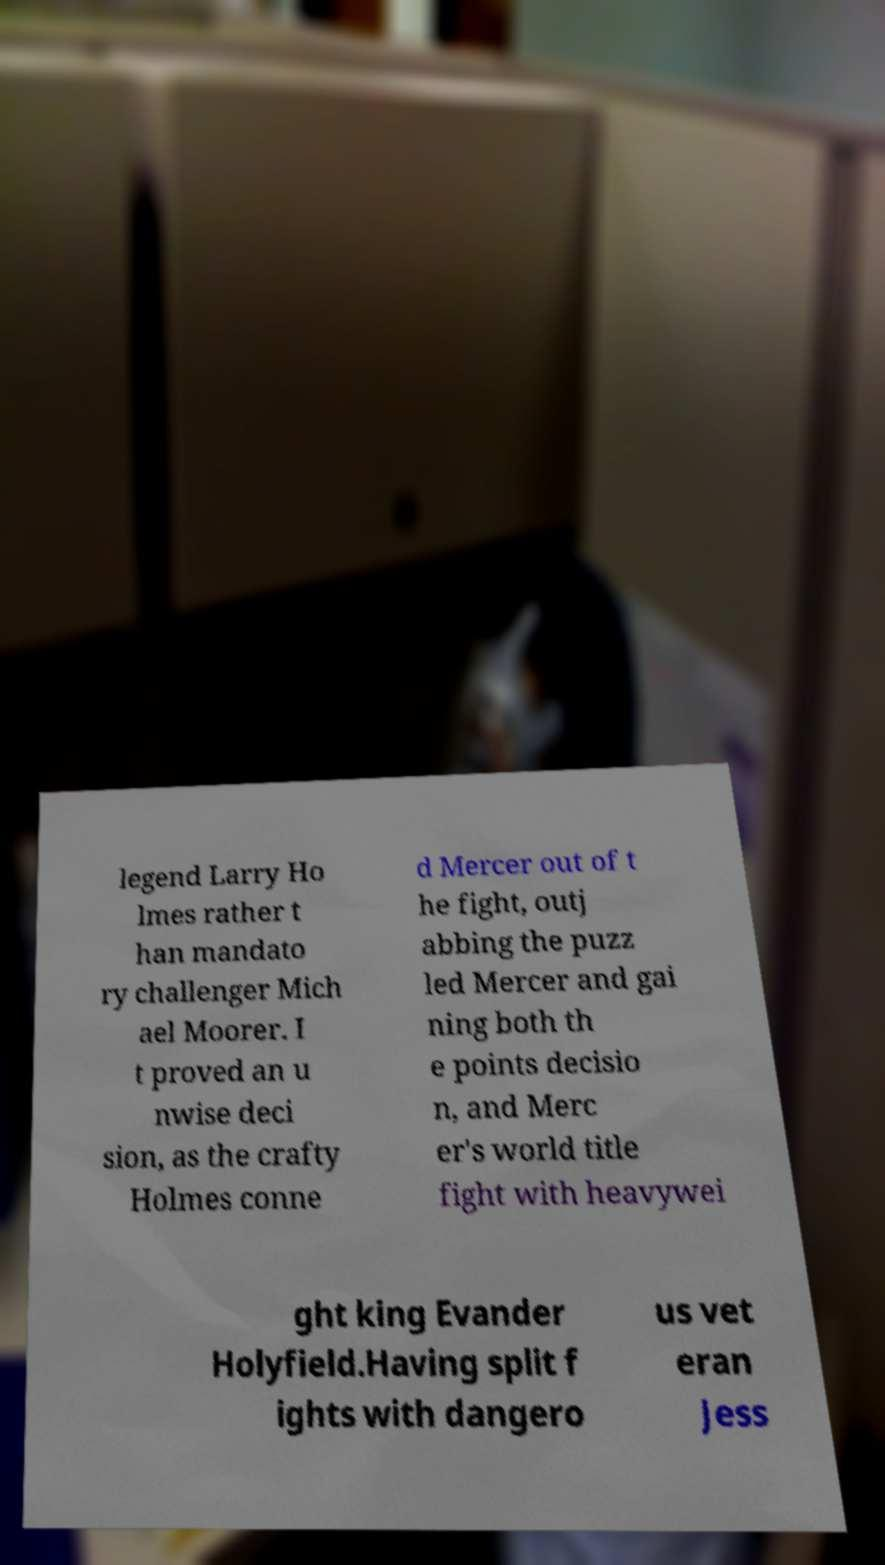For documentation purposes, I need the text within this image transcribed. Could you provide that? legend Larry Ho lmes rather t han mandato ry challenger Mich ael Moorer. I t proved an u nwise deci sion, as the crafty Holmes conne d Mercer out of t he fight, outj abbing the puzz led Mercer and gai ning both th e points decisio n, and Merc er's world title fight with heavywei ght king Evander Holyfield.Having split f ights with dangero us vet eran Jess 